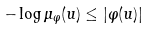<formula> <loc_0><loc_0><loc_500><loc_500>- \log \mu _ { \varphi } ( u ) \leq | \varphi ( u ) |</formula> 